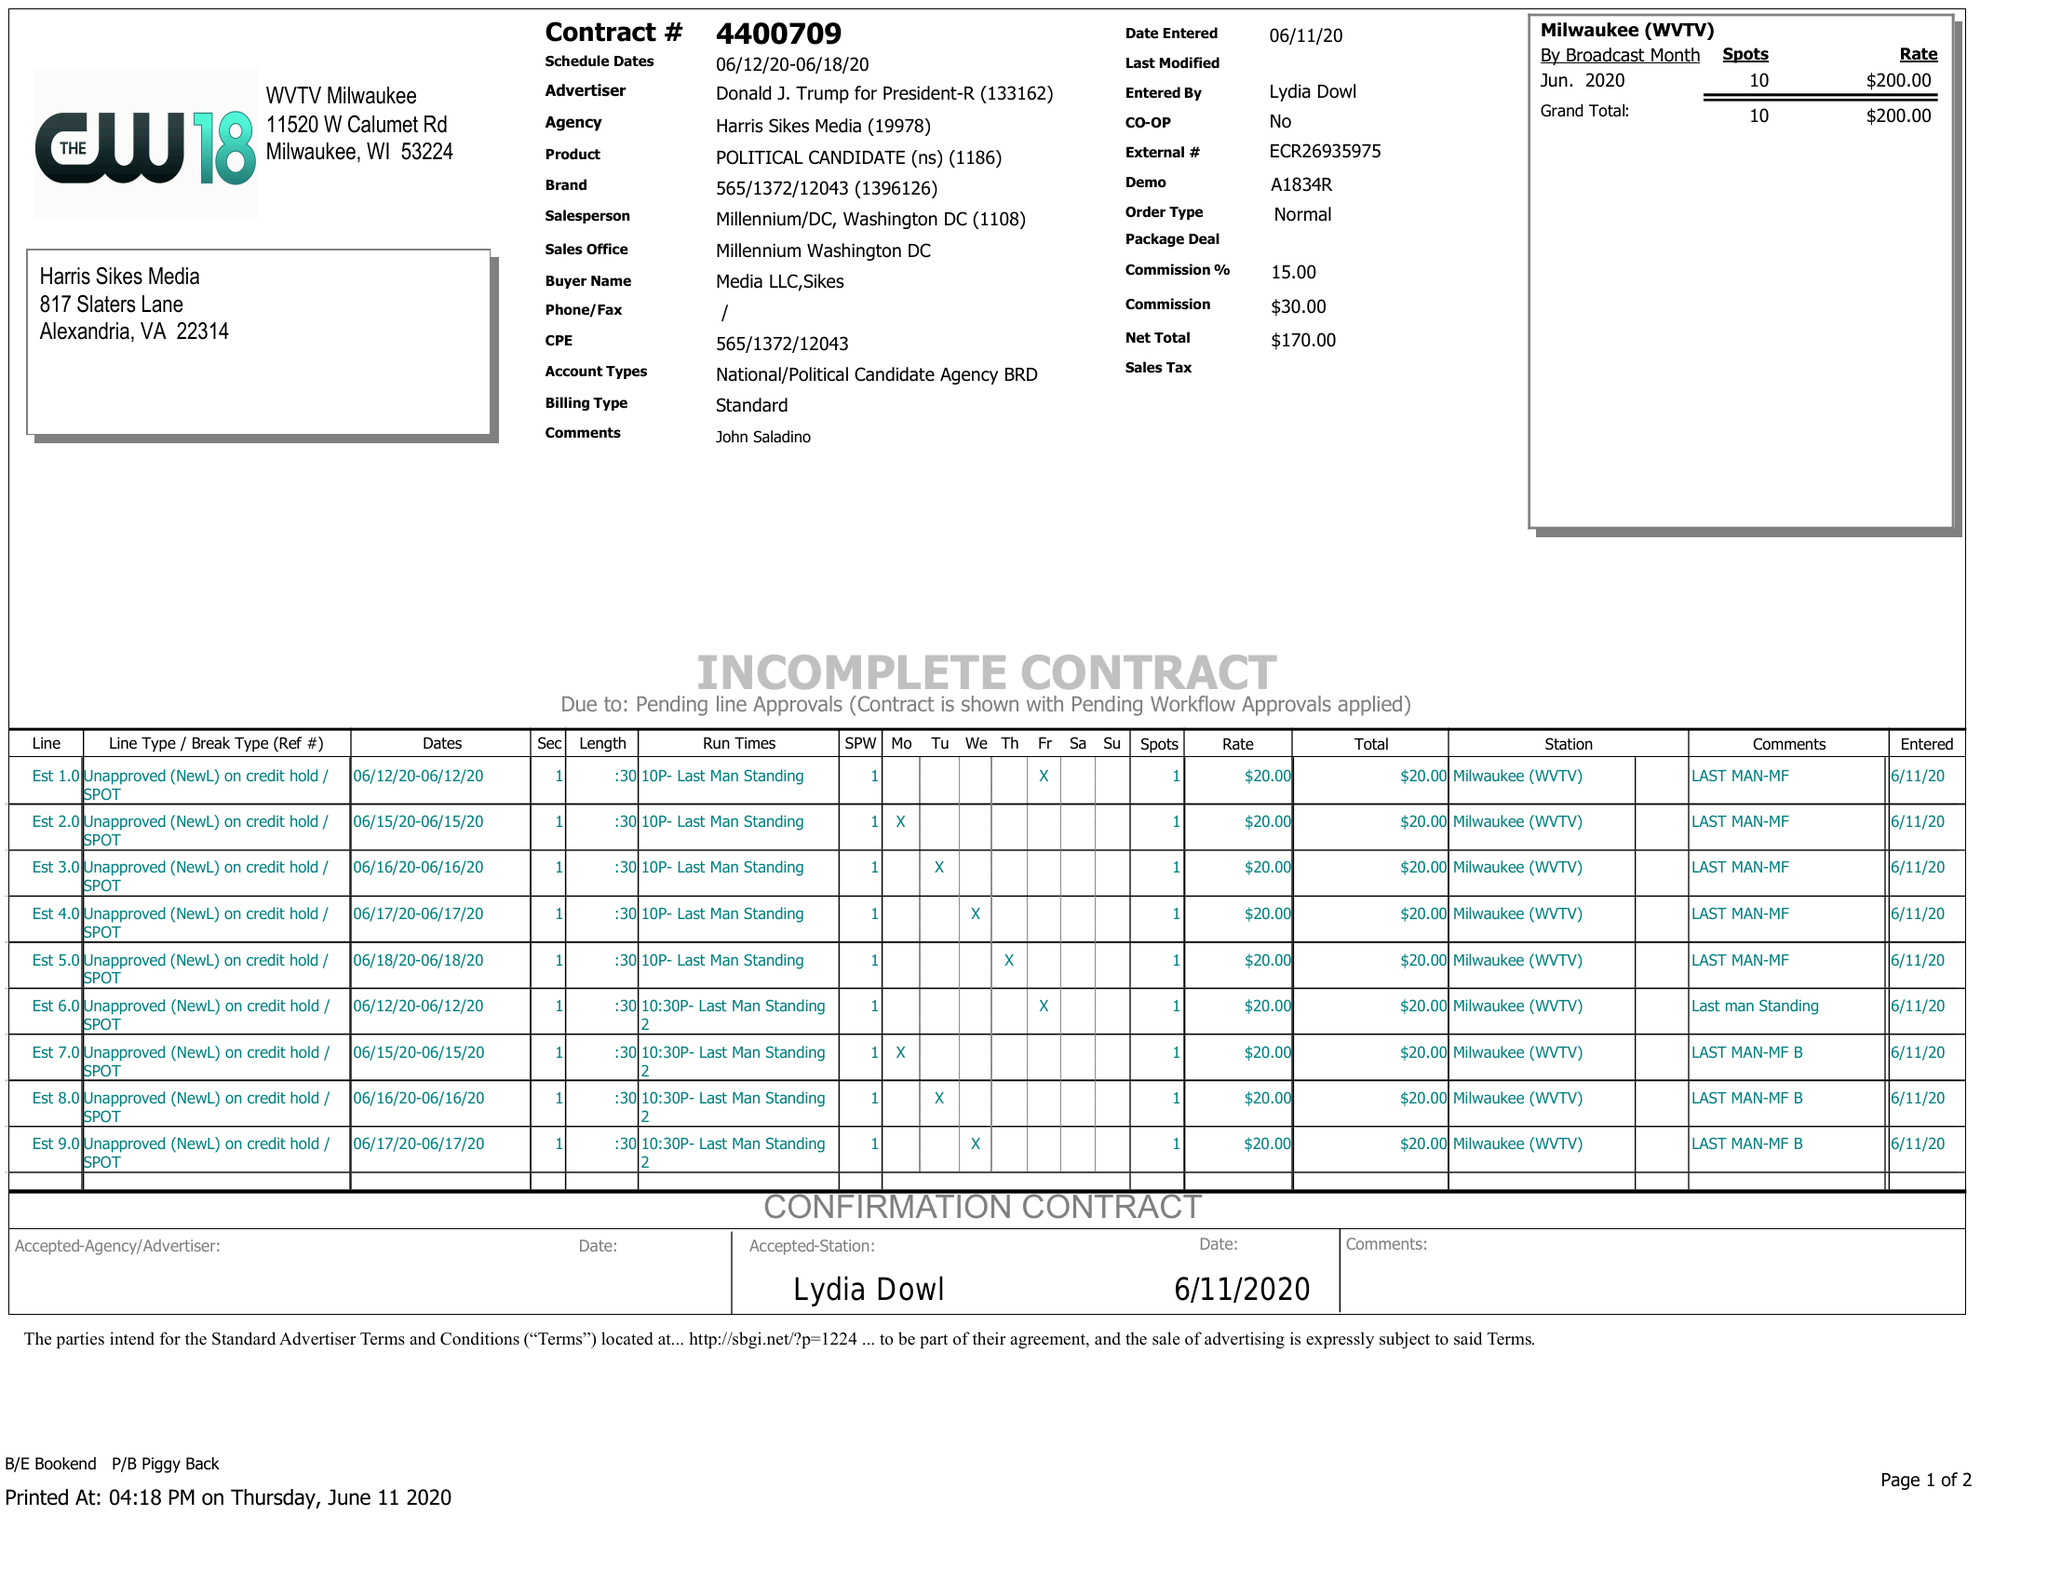What is the value for the advertiser?
Answer the question using a single word or phrase. DONALD J. TRUMP FOR PRESIDENT-R 